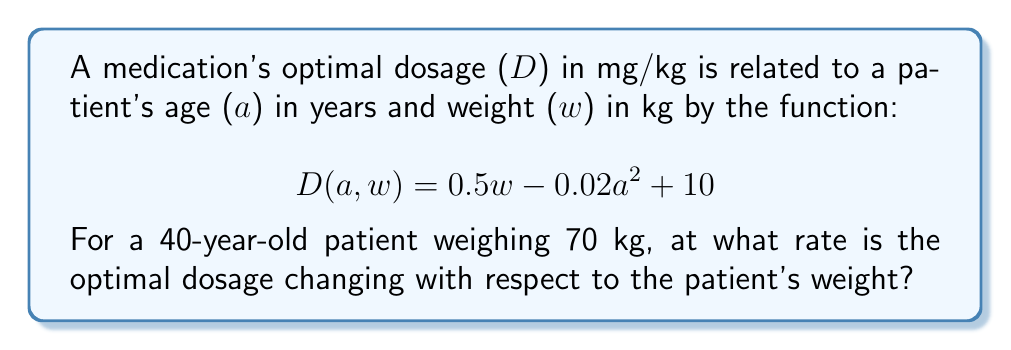Give your solution to this math problem. To solve this problem, we need to find the partial derivative of D with respect to w at the given values of a and w.

1) First, let's identify the partial derivative with respect to w:
   $$\frac{\partial D}{\partial w} = 0.5$$

2) This partial derivative is constant, meaning it doesn't depend on a or w. Therefore, the rate of change of the optimal dosage with respect to weight is always 0.5 mg/kg per kg.

3) We don't need to substitute the given values because the result is independent of a and w.

4) Interpreting the result: For every 1 kg increase in the patient's weight, the optimal dosage increases by 0.5 mg/kg.

Note: While the patient's age is given (40 years) and weight is given (70 kg), these values don't affect the rate of change with respect to weight in this particular function.
Answer: $0.5$ mg/kg per kg 